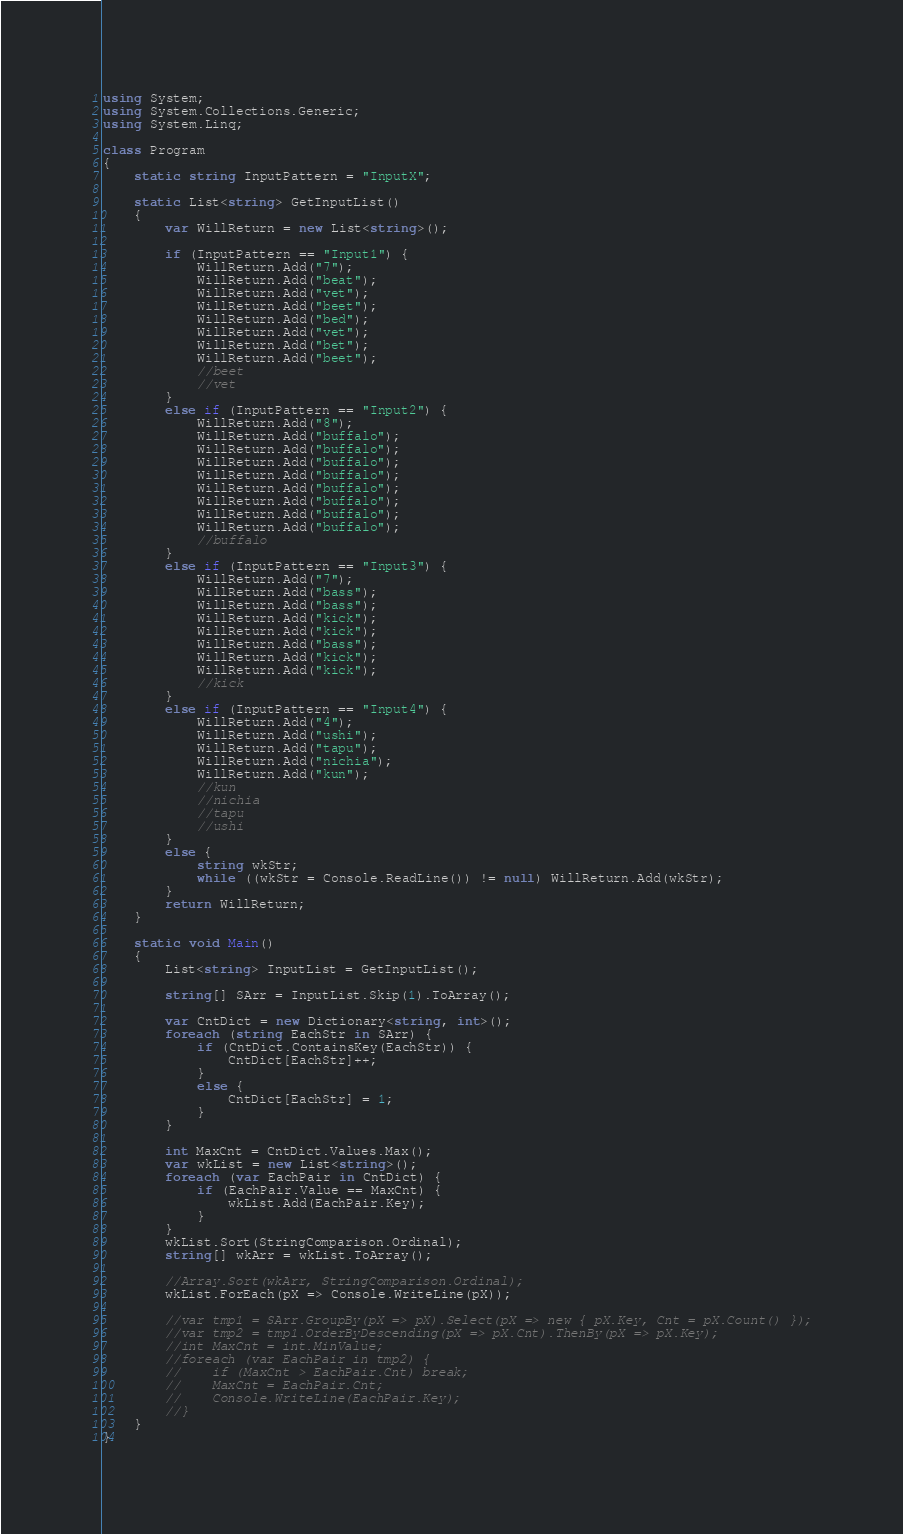<code> <loc_0><loc_0><loc_500><loc_500><_C#_>using System;
using System.Collections.Generic;
using System.Linq;

class Program
{
    static string InputPattern = "InputX";

    static List<string> GetInputList()
    {
        var WillReturn = new List<string>();

        if (InputPattern == "Input1") {
            WillReturn.Add("7");
            WillReturn.Add("beat");
            WillReturn.Add("vet");
            WillReturn.Add("beet");
            WillReturn.Add("bed");
            WillReturn.Add("vet");
            WillReturn.Add("bet");
            WillReturn.Add("beet");
            //beet
            //vet
        }
        else if (InputPattern == "Input2") {
            WillReturn.Add("8");
            WillReturn.Add("buffalo");
            WillReturn.Add("buffalo");
            WillReturn.Add("buffalo");
            WillReturn.Add("buffalo");
            WillReturn.Add("buffalo");
            WillReturn.Add("buffalo");
            WillReturn.Add("buffalo");
            WillReturn.Add("buffalo");
            //buffalo
        }
        else if (InputPattern == "Input3") {
            WillReturn.Add("7");
            WillReturn.Add("bass");
            WillReturn.Add("bass");
            WillReturn.Add("kick");
            WillReturn.Add("kick");
            WillReturn.Add("bass");
            WillReturn.Add("kick");
            WillReturn.Add("kick");
            //kick
        }
        else if (InputPattern == "Input4") {
            WillReturn.Add("4");
            WillReturn.Add("ushi");
            WillReturn.Add("tapu");
            WillReturn.Add("nichia");
            WillReturn.Add("kun");
            //kun
            //nichia
            //tapu
            //ushi
        }
        else {
            string wkStr;
            while ((wkStr = Console.ReadLine()) != null) WillReturn.Add(wkStr);
        }
        return WillReturn;
    }

    static void Main()
    {
        List<string> InputList = GetInputList();

        string[] SArr = InputList.Skip(1).ToArray();

        var CntDict = new Dictionary<string, int>();
        foreach (string EachStr in SArr) {
            if (CntDict.ContainsKey(EachStr)) {
                CntDict[EachStr]++;
            }
            else {
                CntDict[EachStr] = 1;
            }
        }

        int MaxCnt = CntDict.Values.Max();
        var wkList = new List<string>();
        foreach (var EachPair in CntDict) {
            if (EachPair.Value == MaxCnt) {
                wkList.Add(EachPair.Key);
            }
        }
        wkList.Sort(StringComparison.Ordinal);
        string[] wkArr = wkList.ToArray();

        //Array.Sort(wkArr, StringComparison.Ordinal);
        wkList.ForEach(pX => Console.WriteLine(pX));

        //var tmp1 = SArr.GroupBy(pX => pX).Select(pX => new { pX.Key, Cnt = pX.Count() });
        //var tmp2 = tmp1.OrderByDescending(pX => pX.Cnt).ThenBy(pX => pX.Key);
        //int MaxCnt = int.MinValue;
        //foreach (var EachPair in tmp2) {
        //    if (MaxCnt > EachPair.Cnt) break;
        //    MaxCnt = EachPair.Cnt;
        //    Console.WriteLine(EachPair.Key);
        //}
    }
}
</code> 